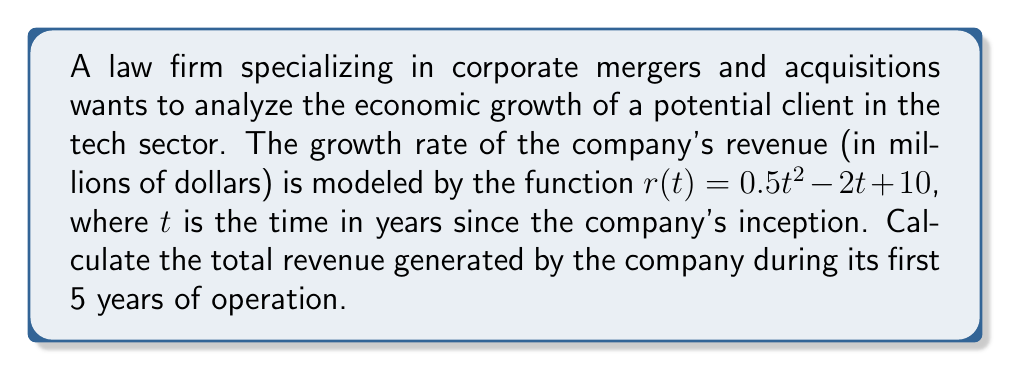Can you solve this math problem? To find the total revenue generated over the first 5 years, we need to integrate the growth rate function from $t=0$ to $t=5$. This is because the integral of the rate of change gives us the total change over the interval.

Step 1: Set up the definite integral
$$\int_0^5 (0.5t^2 - 2t + 10) dt$$

Step 2: Integrate the function
$$\left[\frac{0.5t^3}{3} - t^2 + 10t\right]_0^5$$

Step 3: Evaluate the integral at the upper and lower bounds
Upper bound (t = 5):
$$\frac{0.5(5^3)}{3} - 5^2 + 10(5) = \frac{125}{3} - 25 + 50 = \frac{125}{3} + 25 = \frac{200}{3}$$

Lower bound (t = 0):
$$\frac{0.5(0^3)}{3} - 0^2 + 10(0) = 0$$

Step 4: Subtract the lower bound from the upper bound
$$\frac{200}{3} - 0 = \frac{200}{3}$$

Therefore, the total revenue generated over the first 5 years is $\frac{200}{3}$ million dollars.
Answer: $\frac{200}{3}$ million dollars 